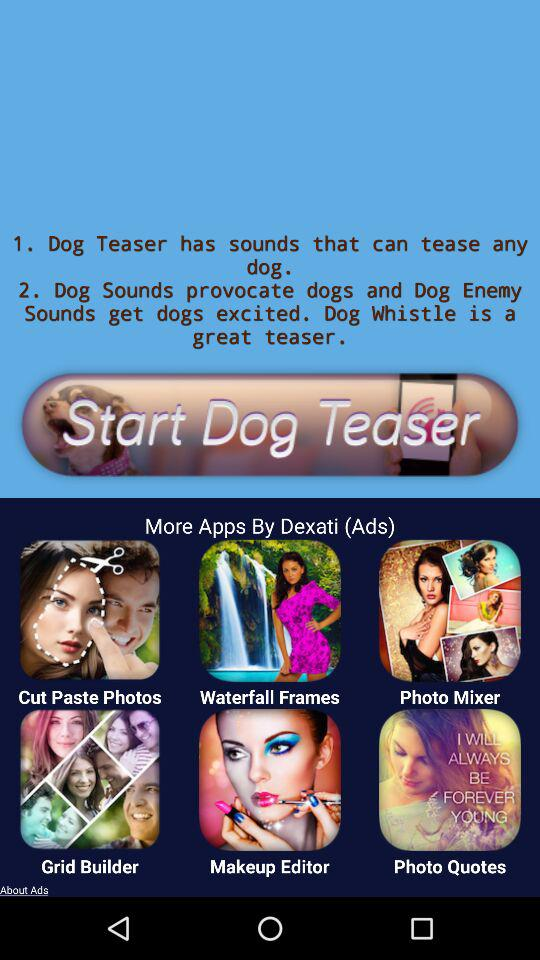What is the name of the application? The application names are "Dog Teaser", "Cut Paste Photos", "Waterfall Frames", "Photo Mixer", "Grid Builder", "Makeup Editor" and "Photo Quotes". 